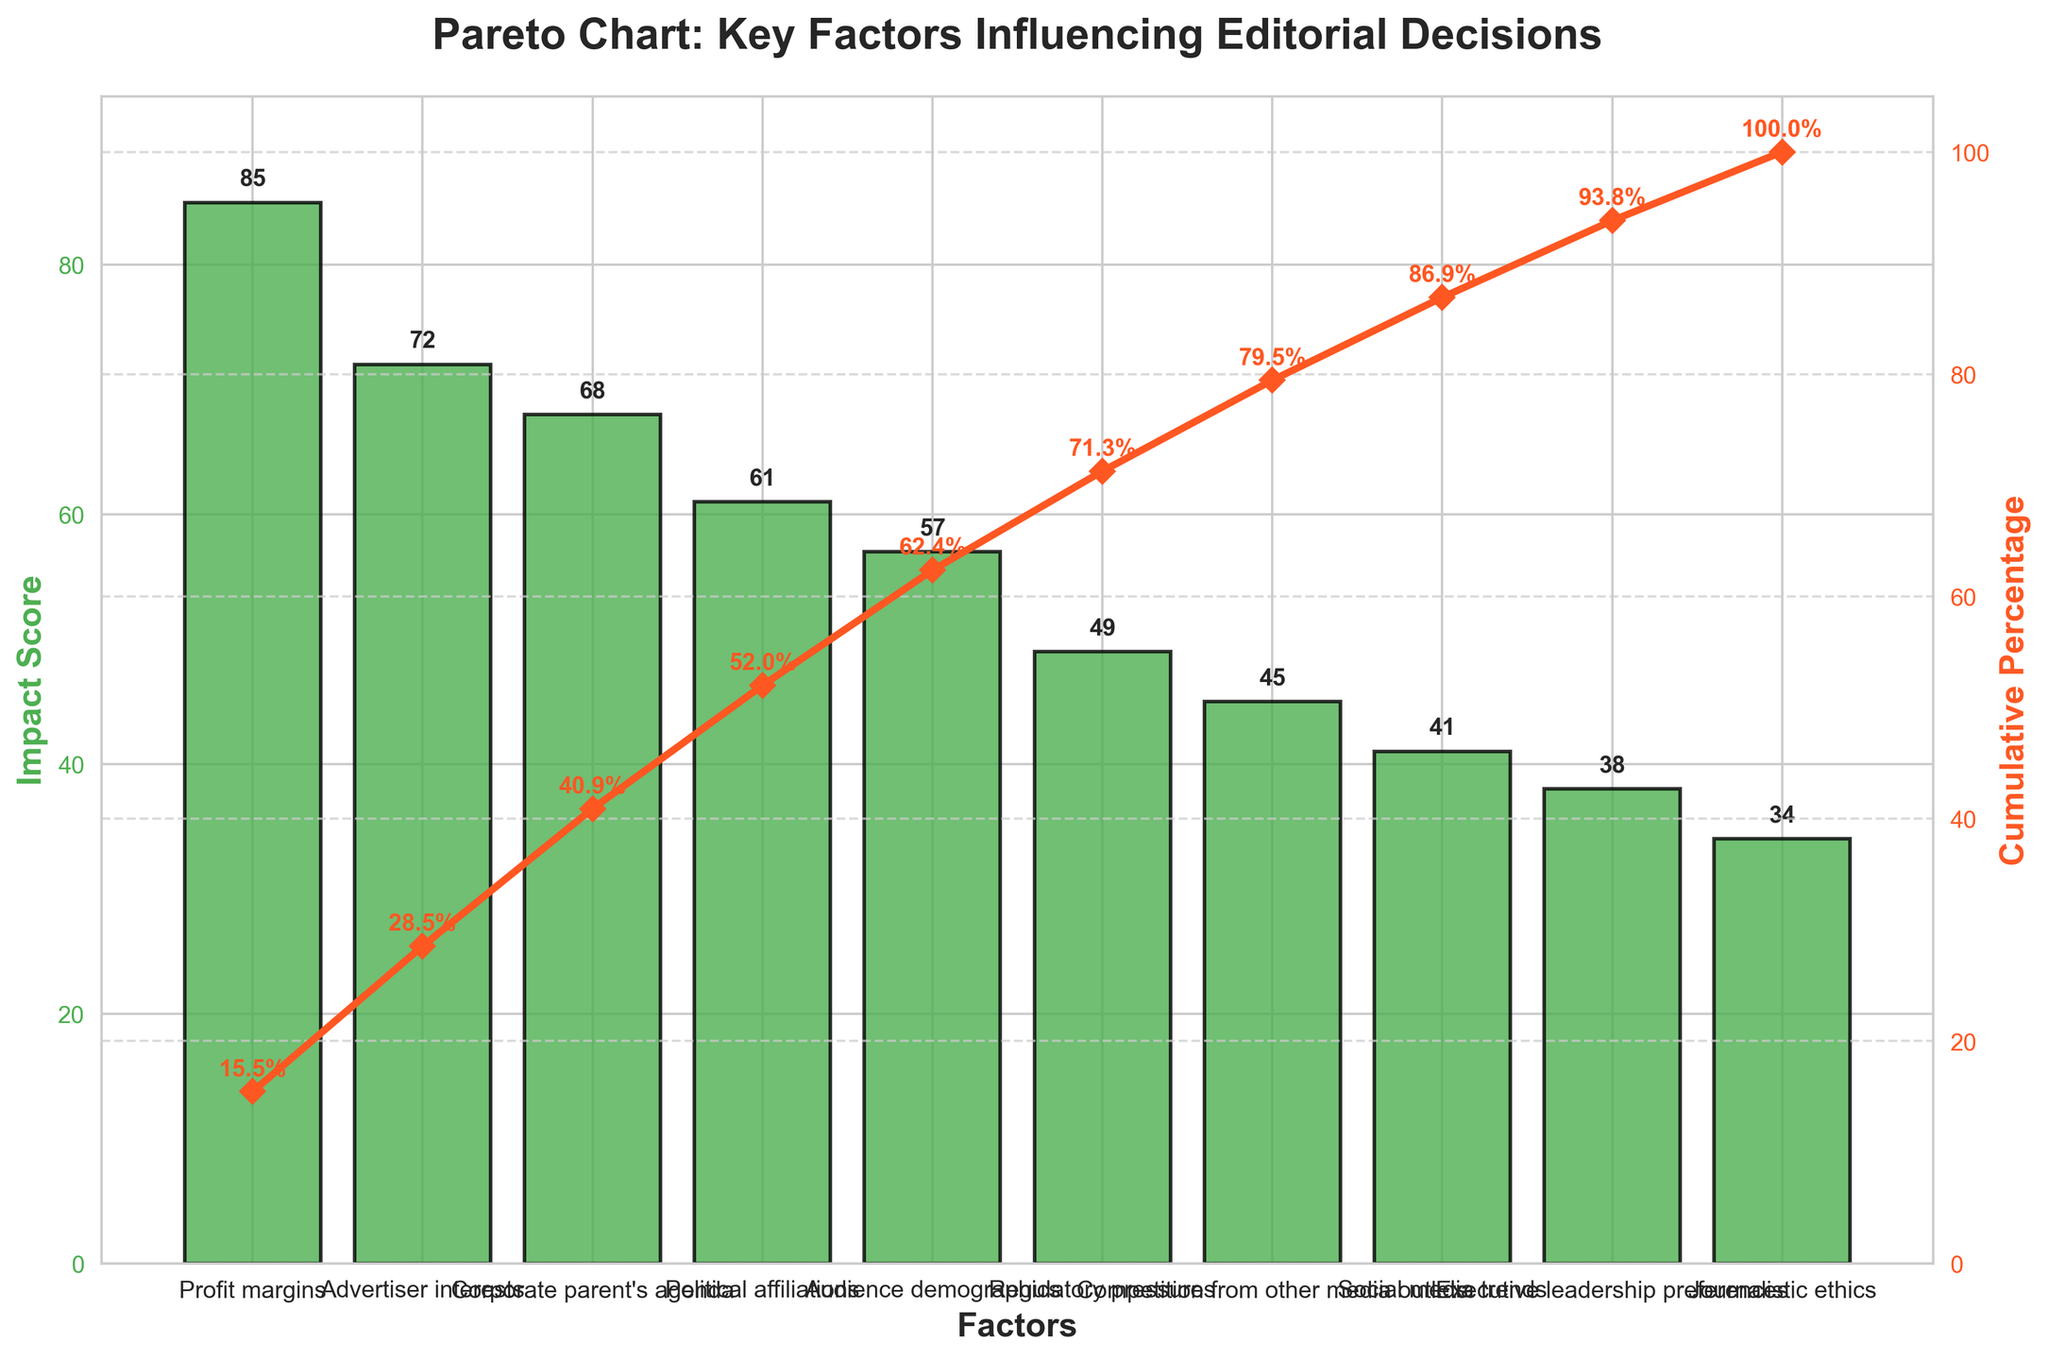What is the title of the plot? The title is located at the top center of the plot. It describes what the plot is about.
Answer: Pareto Chart: Key Factors Influencing Editorial Decisions Which factor has the highest impact score? The highest bar represents the factor with the highest impact score.
Answer: Profit margins What is the impact score of 'Corporate parent's agenda'? The impact score is noted at the top of the bar corresponding to 'Corporate parent's agenda.'
Answer: 68 Which factors are responsible for more than 50% of the cumulative impact? Add up the cumulative percentages as you move along the x-axis until they surpass 50%. The factors contributing to this cumulative percentage are those responsible for more than 50% of the impact.
Answer: Profit margins, Advertiser interests, Corporate parent's agenda, Political affiliations How does the impact of 'Journalistic ethics' compare to 'Executive leadership preferences'? Compare the heights of the bars for 'Journalistic ethics' and 'Executive leadership preferences.'
Answer: Journalistic ethics has a lower score What cumulative percentage does 'Advertiser interests' contribute to? Look at the cumulative line plot and identify the percentage value at the point corresponding to 'Advertiser interests.'
Answer: 75.7% What is the difference in impact score between 'Audience demographics' and 'Social media trends'? Subtract the impact score of 'Social media trends' from 'Audience demographics.'
Answer: 16 Which factor has the lowest impact score, and what is it? The shortest bar represents the factor with the lowest impact score.
Answer: Journalistic ethics, 34 What percentage of the total impact do the top three factors contribute to? Sum the impact scores of the top three factors and divide by the total impact score, then multiply by 100.
Answer: 72.4% How many factors have an impact score above 60? Count the number of bars that have an impact score higher than 60.
Answer: 4 